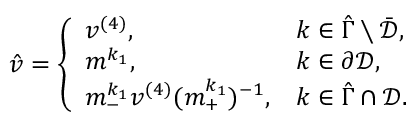Convert formula to latex. <formula><loc_0><loc_0><loc_500><loc_500>\begin{array} { r } { \hat { v } = \left \{ \begin{array} { l l } { v ^ { ( 4 ) } , } & { k \in \hat { \Gamma } \ \bar { \mathcal { D } } , } \\ { m ^ { k _ { 1 } } , } & { k \in \partial \mathcal { D } , } \\ { m _ { - } ^ { k _ { 1 } } v ^ { ( 4 ) } ( m _ { + } ^ { k _ { 1 } } ) ^ { - 1 } , } & { k \in \hat { \Gamma } \cap \mathcal { D } . } \end{array} } \end{array}</formula> 